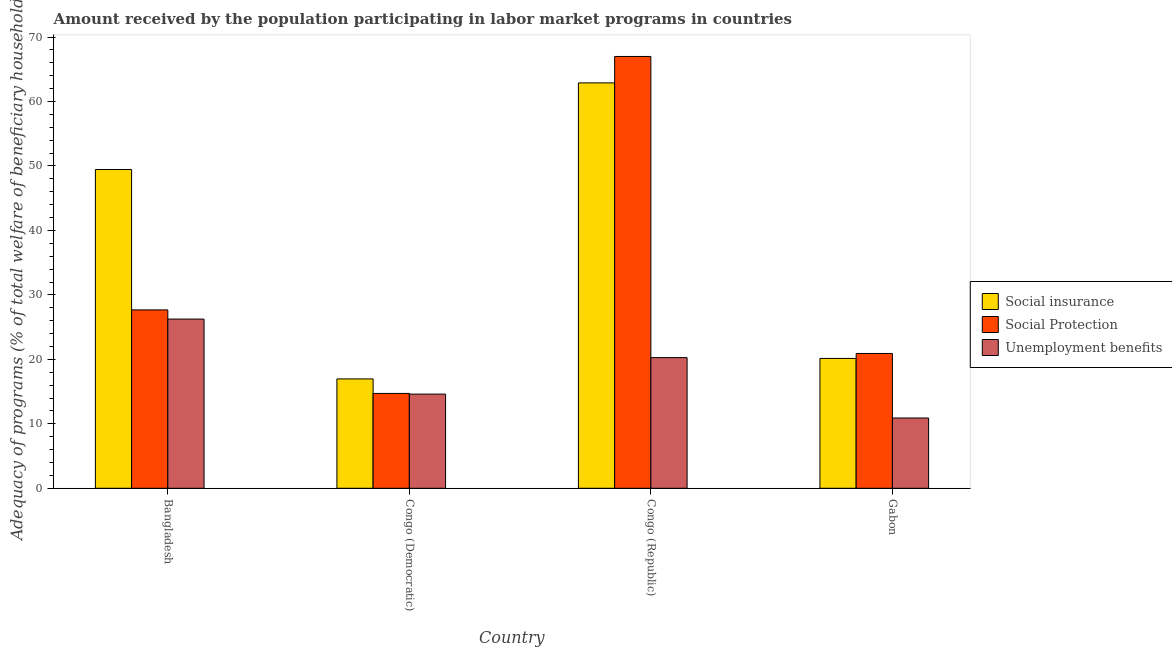How many different coloured bars are there?
Provide a succinct answer. 3. How many groups of bars are there?
Ensure brevity in your answer.  4. Are the number of bars per tick equal to the number of legend labels?
Provide a succinct answer. Yes. What is the label of the 2nd group of bars from the left?
Give a very brief answer. Congo (Democratic). What is the amount received by the population participating in social insurance programs in Bangladesh?
Give a very brief answer. 49.45. Across all countries, what is the maximum amount received by the population participating in unemployment benefits programs?
Give a very brief answer. 26.25. Across all countries, what is the minimum amount received by the population participating in unemployment benefits programs?
Keep it short and to the point. 10.9. In which country was the amount received by the population participating in social protection programs maximum?
Provide a succinct answer. Congo (Republic). In which country was the amount received by the population participating in social insurance programs minimum?
Your answer should be very brief. Congo (Democratic). What is the total amount received by the population participating in social insurance programs in the graph?
Your answer should be very brief. 149.45. What is the difference between the amount received by the population participating in social insurance programs in Bangladesh and that in Gabon?
Make the answer very short. 29.31. What is the difference between the amount received by the population participating in social protection programs in Bangladesh and the amount received by the population participating in social insurance programs in Congo (Democratic)?
Ensure brevity in your answer.  10.71. What is the average amount received by the population participating in social insurance programs per country?
Your response must be concise. 37.36. What is the difference between the amount received by the population participating in social protection programs and amount received by the population participating in unemployment benefits programs in Gabon?
Your response must be concise. 10.01. What is the ratio of the amount received by the population participating in social protection programs in Congo (Democratic) to that in Gabon?
Keep it short and to the point. 0.7. Is the amount received by the population participating in social protection programs in Congo (Democratic) less than that in Congo (Republic)?
Your answer should be very brief. Yes. What is the difference between the highest and the second highest amount received by the population participating in unemployment benefits programs?
Offer a very short reply. 5.98. What is the difference between the highest and the lowest amount received by the population participating in unemployment benefits programs?
Your answer should be very brief. 15.35. In how many countries, is the amount received by the population participating in social insurance programs greater than the average amount received by the population participating in social insurance programs taken over all countries?
Provide a short and direct response. 2. Is the sum of the amount received by the population participating in social insurance programs in Congo (Republic) and Gabon greater than the maximum amount received by the population participating in social protection programs across all countries?
Give a very brief answer. Yes. What does the 1st bar from the left in Congo (Republic) represents?
Ensure brevity in your answer.  Social insurance. What does the 2nd bar from the right in Gabon represents?
Your answer should be compact. Social Protection. Is it the case that in every country, the sum of the amount received by the population participating in social insurance programs and amount received by the population participating in social protection programs is greater than the amount received by the population participating in unemployment benefits programs?
Keep it short and to the point. Yes. Are all the bars in the graph horizontal?
Provide a short and direct response. No. How many countries are there in the graph?
Your response must be concise. 4. Does the graph contain grids?
Offer a very short reply. No. How are the legend labels stacked?
Keep it short and to the point. Vertical. What is the title of the graph?
Give a very brief answer. Amount received by the population participating in labor market programs in countries. What is the label or title of the X-axis?
Your answer should be very brief. Country. What is the label or title of the Y-axis?
Keep it short and to the point. Adequacy of programs (% of total welfare of beneficiary households). What is the Adequacy of programs (% of total welfare of beneficiary households) of Social insurance in Bangladesh?
Your answer should be compact. 49.45. What is the Adequacy of programs (% of total welfare of beneficiary households) of Social Protection in Bangladesh?
Offer a terse response. 27.67. What is the Adequacy of programs (% of total welfare of beneficiary households) of Unemployment benefits in Bangladesh?
Provide a succinct answer. 26.25. What is the Adequacy of programs (% of total welfare of beneficiary households) in Social insurance in Congo (Democratic)?
Provide a short and direct response. 16.97. What is the Adequacy of programs (% of total welfare of beneficiary households) of Social Protection in Congo (Democratic)?
Provide a short and direct response. 14.72. What is the Adequacy of programs (% of total welfare of beneficiary households) in Unemployment benefits in Congo (Democratic)?
Provide a succinct answer. 14.61. What is the Adequacy of programs (% of total welfare of beneficiary households) of Social insurance in Congo (Republic)?
Offer a terse response. 62.89. What is the Adequacy of programs (% of total welfare of beneficiary households) of Social Protection in Congo (Republic)?
Offer a very short reply. 66.99. What is the Adequacy of programs (% of total welfare of beneficiary households) of Unemployment benefits in Congo (Republic)?
Ensure brevity in your answer.  20.27. What is the Adequacy of programs (% of total welfare of beneficiary households) in Social insurance in Gabon?
Ensure brevity in your answer.  20.14. What is the Adequacy of programs (% of total welfare of beneficiary households) in Social Protection in Gabon?
Offer a very short reply. 20.91. What is the Adequacy of programs (% of total welfare of beneficiary households) in Unemployment benefits in Gabon?
Ensure brevity in your answer.  10.9. Across all countries, what is the maximum Adequacy of programs (% of total welfare of beneficiary households) in Social insurance?
Your answer should be compact. 62.89. Across all countries, what is the maximum Adequacy of programs (% of total welfare of beneficiary households) in Social Protection?
Offer a very short reply. 66.99. Across all countries, what is the maximum Adequacy of programs (% of total welfare of beneficiary households) in Unemployment benefits?
Your response must be concise. 26.25. Across all countries, what is the minimum Adequacy of programs (% of total welfare of beneficiary households) of Social insurance?
Make the answer very short. 16.97. Across all countries, what is the minimum Adequacy of programs (% of total welfare of beneficiary households) of Social Protection?
Provide a short and direct response. 14.72. Across all countries, what is the minimum Adequacy of programs (% of total welfare of beneficiary households) of Unemployment benefits?
Ensure brevity in your answer.  10.9. What is the total Adequacy of programs (% of total welfare of beneficiary households) of Social insurance in the graph?
Keep it short and to the point. 149.46. What is the total Adequacy of programs (% of total welfare of beneficiary households) of Social Protection in the graph?
Offer a terse response. 130.3. What is the total Adequacy of programs (% of total welfare of beneficiary households) of Unemployment benefits in the graph?
Give a very brief answer. 72.04. What is the difference between the Adequacy of programs (% of total welfare of beneficiary households) of Social insurance in Bangladesh and that in Congo (Democratic)?
Ensure brevity in your answer.  32.49. What is the difference between the Adequacy of programs (% of total welfare of beneficiary households) in Social Protection in Bangladesh and that in Congo (Democratic)?
Your answer should be very brief. 12.96. What is the difference between the Adequacy of programs (% of total welfare of beneficiary households) of Unemployment benefits in Bangladesh and that in Congo (Democratic)?
Provide a succinct answer. 11.64. What is the difference between the Adequacy of programs (% of total welfare of beneficiary households) in Social insurance in Bangladesh and that in Congo (Republic)?
Offer a terse response. -13.44. What is the difference between the Adequacy of programs (% of total welfare of beneficiary households) of Social Protection in Bangladesh and that in Congo (Republic)?
Provide a short and direct response. -39.32. What is the difference between the Adequacy of programs (% of total welfare of beneficiary households) in Unemployment benefits in Bangladesh and that in Congo (Republic)?
Provide a short and direct response. 5.98. What is the difference between the Adequacy of programs (% of total welfare of beneficiary households) in Social insurance in Bangladesh and that in Gabon?
Give a very brief answer. 29.31. What is the difference between the Adequacy of programs (% of total welfare of beneficiary households) in Social Protection in Bangladesh and that in Gabon?
Offer a terse response. 6.76. What is the difference between the Adequacy of programs (% of total welfare of beneficiary households) of Unemployment benefits in Bangladesh and that in Gabon?
Make the answer very short. 15.35. What is the difference between the Adequacy of programs (% of total welfare of beneficiary households) of Social insurance in Congo (Democratic) and that in Congo (Republic)?
Your answer should be compact. -45.92. What is the difference between the Adequacy of programs (% of total welfare of beneficiary households) of Social Protection in Congo (Democratic) and that in Congo (Republic)?
Make the answer very short. -52.28. What is the difference between the Adequacy of programs (% of total welfare of beneficiary households) of Unemployment benefits in Congo (Democratic) and that in Congo (Republic)?
Make the answer very short. -5.66. What is the difference between the Adequacy of programs (% of total welfare of beneficiary households) of Social insurance in Congo (Democratic) and that in Gabon?
Provide a short and direct response. -3.18. What is the difference between the Adequacy of programs (% of total welfare of beneficiary households) of Social Protection in Congo (Democratic) and that in Gabon?
Offer a very short reply. -6.2. What is the difference between the Adequacy of programs (% of total welfare of beneficiary households) in Unemployment benefits in Congo (Democratic) and that in Gabon?
Provide a short and direct response. 3.71. What is the difference between the Adequacy of programs (% of total welfare of beneficiary households) of Social insurance in Congo (Republic) and that in Gabon?
Provide a succinct answer. 42.75. What is the difference between the Adequacy of programs (% of total welfare of beneficiary households) of Social Protection in Congo (Republic) and that in Gabon?
Keep it short and to the point. 46.08. What is the difference between the Adequacy of programs (% of total welfare of beneficiary households) of Unemployment benefits in Congo (Republic) and that in Gabon?
Give a very brief answer. 9.37. What is the difference between the Adequacy of programs (% of total welfare of beneficiary households) of Social insurance in Bangladesh and the Adequacy of programs (% of total welfare of beneficiary households) of Social Protection in Congo (Democratic)?
Provide a succinct answer. 34.74. What is the difference between the Adequacy of programs (% of total welfare of beneficiary households) of Social insurance in Bangladesh and the Adequacy of programs (% of total welfare of beneficiary households) of Unemployment benefits in Congo (Democratic)?
Offer a very short reply. 34.84. What is the difference between the Adequacy of programs (% of total welfare of beneficiary households) of Social Protection in Bangladesh and the Adequacy of programs (% of total welfare of beneficiary households) of Unemployment benefits in Congo (Democratic)?
Offer a terse response. 13.06. What is the difference between the Adequacy of programs (% of total welfare of beneficiary households) in Social insurance in Bangladesh and the Adequacy of programs (% of total welfare of beneficiary households) in Social Protection in Congo (Republic)?
Your response must be concise. -17.54. What is the difference between the Adequacy of programs (% of total welfare of beneficiary households) of Social insurance in Bangladesh and the Adequacy of programs (% of total welfare of beneficiary households) of Unemployment benefits in Congo (Republic)?
Give a very brief answer. 29.18. What is the difference between the Adequacy of programs (% of total welfare of beneficiary households) of Social Protection in Bangladesh and the Adequacy of programs (% of total welfare of beneficiary households) of Unemployment benefits in Congo (Republic)?
Provide a succinct answer. 7.4. What is the difference between the Adequacy of programs (% of total welfare of beneficiary households) in Social insurance in Bangladesh and the Adequacy of programs (% of total welfare of beneficiary households) in Social Protection in Gabon?
Offer a terse response. 28.54. What is the difference between the Adequacy of programs (% of total welfare of beneficiary households) of Social insurance in Bangladesh and the Adequacy of programs (% of total welfare of beneficiary households) of Unemployment benefits in Gabon?
Your response must be concise. 38.55. What is the difference between the Adequacy of programs (% of total welfare of beneficiary households) in Social Protection in Bangladesh and the Adequacy of programs (% of total welfare of beneficiary households) in Unemployment benefits in Gabon?
Provide a short and direct response. 16.77. What is the difference between the Adequacy of programs (% of total welfare of beneficiary households) in Social insurance in Congo (Democratic) and the Adequacy of programs (% of total welfare of beneficiary households) in Social Protection in Congo (Republic)?
Your answer should be very brief. -50.03. What is the difference between the Adequacy of programs (% of total welfare of beneficiary households) in Social insurance in Congo (Democratic) and the Adequacy of programs (% of total welfare of beneficiary households) in Unemployment benefits in Congo (Republic)?
Give a very brief answer. -3.31. What is the difference between the Adequacy of programs (% of total welfare of beneficiary households) in Social Protection in Congo (Democratic) and the Adequacy of programs (% of total welfare of beneficiary households) in Unemployment benefits in Congo (Republic)?
Provide a succinct answer. -5.56. What is the difference between the Adequacy of programs (% of total welfare of beneficiary households) of Social insurance in Congo (Democratic) and the Adequacy of programs (% of total welfare of beneficiary households) of Social Protection in Gabon?
Make the answer very short. -3.95. What is the difference between the Adequacy of programs (% of total welfare of beneficiary households) in Social insurance in Congo (Democratic) and the Adequacy of programs (% of total welfare of beneficiary households) in Unemployment benefits in Gabon?
Your answer should be compact. 6.06. What is the difference between the Adequacy of programs (% of total welfare of beneficiary households) in Social Protection in Congo (Democratic) and the Adequacy of programs (% of total welfare of beneficiary households) in Unemployment benefits in Gabon?
Provide a succinct answer. 3.81. What is the difference between the Adequacy of programs (% of total welfare of beneficiary households) of Social insurance in Congo (Republic) and the Adequacy of programs (% of total welfare of beneficiary households) of Social Protection in Gabon?
Your answer should be compact. 41.98. What is the difference between the Adequacy of programs (% of total welfare of beneficiary households) in Social insurance in Congo (Republic) and the Adequacy of programs (% of total welfare of beneficiary households) in Unemployment benefits in Gabon?
Give a very brief answer. 51.99. What is the difference between the Adequacy of programs (% of total welfare of beneficiary households) in Social Protection in Congo (Republic) and the Adequacy of programs (% of total welfare of beneficiary households) in Unemployment benefits in Gabon?
Ensure brevity in your answer.  56.09. What is the average Adequacy of programs (% of total welfare of beneficiary households) in Social insurance per country?
Ensure brevity in your answer.  37.36. What is the average Adequacy of programs (% of total welfare of beneficiary households) of Social Protection per country?
Ensure brevity in your answer.  32.57. What is the average Adequacy of programs (% of total welfare of beneficiary households) in Unemployment benefits per country?
Provide a short and direct response. 18.01. What is the difference between the Adequacy of programs (% of total welfare of beneficiary households) of Social insurance and Adequacy of programs (% of total welfare of beneficiary households) of Social Protection in Bangladesh?
Your answer should be compact. 21.78. What is the difference between the Adequacy of programs (% of total welfare of beneficiary households) of Social insurance and Adequacy of programs (% of total welfare of beneficiary households) of Unemployment benefits in Bangladesh?
Give a very brief answer. 23.2. What is the difference between the Adequacy of programs (% of total welfare of beneficiary households) of Social Protection and Adequacy of programs (% of total welfare of beneficiary households) of Unemployment benefits in Bangladesh?
Give a very brief answer. 1.42. What is the difference between the Adequacy of programs (% of total welfare of beneficiary households) in Social insurance and Adequacy of programs (% of total welfare of beneficiary households) in Social Protection in Congo (Democratic)?
Your response must be concise. 2.25. What is the difference between the Adequacy of programs (% of total welfare of beneficiary households) in Social insurance and Adequacy of programs (% of total welfare of beneficiary households) in Unemployment benefits in Congo (Democratic)?
Your response must be concise. 2.36. What is the difference between the Adequacy of programs (% of total welfare of beneficiary households) of Social Protection and Adequacy of programs (% of total welfare of beneficiary households) of Unemployment benefits in Congo (Democratic)?
Give a very brief answer. 0.11. What is the difference between the Adequacy of programs (% of total welfare of beneficiary households) in Social insurance and Adequacy of programs (% of total welfare of beneficiary households) in Social Protection in Congo (Republic)?
Provide a short and direct response. -4.1. What is the difference between the Adequacy of programs (% of total welfare of beneficiary households) in Social insurance and Adequacy of programs (% of total welfare of beneficiary households) in Unemployment benefits in Congo (Republic)?
Offer a very short reply. 42.62. What is the difference between the Adequacy of programs (% of total welfare of beneficiary households) of Social Protection and Adequacy of programs (% of total welfare of beneficiary households) of Unemployment benefits in Congo (Republic)?
Your answer should be very brief. 46.72. What is the difference between the Adequacy of programs (% of total welfare of beneficiary households) of Social insurance and Adequacy of programs (% of total welfare of beneficiary households) of Social Protection in Gabon?
Offer a terse response. -0.77. What is the difference between the Adequacy of programs (% of total welfare of beneficiary households) of Social insurance and Adequacy of programs (% of total welfare of beneficiary households) of Unemployment benefits in Gabon?
Your response must be concise. 9.24. What is the difference between the Adequacy of programs (% of total welfare of beneficiary households) in Social Protection and Adequacy of programs (% of total welfare of beneficiary households) in Unemployment benefits in Gabon?
Provide a short and direct response. 10.01. What is the ratio of the Adequacy of programs (% of total welfare of beneficiary households) of Social insurance in Bangladesh to that in Congo (Democratic)?
Give a very brief answer. 2.91. What is the ratio of the Adequacy of programs (% of total welfare of beneficiary households) of Social Protection in Bangladesh to that in Congo (Democratic)?
Ensure brevity in your answer.  1.88. What is the ratio of the Adequacy of programs (% of total welfare of beneficiary households) of Unemployment benefits in Bangladesh to that in Congo (Democratic)?
Ensure brevity in your answer.  1.8. What is the ratio of the Adequacy of programs (% of total welfare of beneficiary households) in Social insurance in Bangladesh to that in Congo (Republic)?
Offer a terse response. 0.79. What is the ratio of the Adequacy of programs (% of total welfare of beneficiary households) in Social Protection in Bangladesh to that in Congo (Republic)?
Make the answer very short. 0.41. What is the ratio of the Adequacy of programs (% of total welfare of beneficiary households) in Unemployment benefits in Bangladesh to that in Congo (Republic)?
Your answer should be compact. 1.29. What is the ratio of the Adequacy of programs (% of total welfare of beneficiary households) in Social insurance in Bangladesh to that in Gabon?
Offer a very short reply. 2.45. What is the ratio of the Adequacy of programs (% of total welfare of beneficiary households) in Social Protection in Bangladesh to that in Gabon?
Provide a succinct answer. 1.32. What is the ratio of the Adequacy of programs (% of total welfare of beneficiary households) in Unemployment benefits in Bangladesh to that in Gabon?
Your response must be concise. 2.41. What is the ratio of the Adequacy of programs (% of total welfare of beneficiary households) in Social insurance in Congo (Democratic) to that in Congo (Republic)?
Your answer should be very brief. 0.27. What is the ratio of the Adequacy of programs (% of total welfare of beneficiary households) of Social Protection in Congo (Democratic) to that in Congo (Republic)?
Your response must be concise. 0.22. What is the ratio of the Adequacy of programs (% of total welfare of beneficiary households) in Unemployment benefits in Congo (Democratic) to that in Congo (Republic)?
Make the answer very short. 0.72. What is the ratio of the Adequacy of programs (% of total welfare of beneficiary households) in Social insurance in Congo (Democratic) to that in Gabon?
Offer a terse response. 0.84. What is the ratio of the Adequacy of programs (% of total welfare of beneficiary households) in Social Protection in Congo (Democratic) to that in Gabon?
Provide a succinct answer. 0.7. What is the ratio of the Adequacy of programs (% of total welfare of beneficiary households) in Unemployment benefits in Congo (Democratic) to that in Gabon?
Keep it short and to the point. 1.34. What is the ratio of the Adequacy of programs (% of total welfare of beneficiary households) in Social insurance in Congo (Republic) to that in Gabon?
Provide a short and direct response. 3.12. What is the ratio of the Adequacy of programs (% of total welfare of beneficiary households) in Social Protection in Congo (Republic) to that in Gabon?
Offer a terse response. 3.2. What is the ratio of the Adequacy of programs (% of total welfare of beneficiary households) in Unemployment benefits in Congo (Republic) to that in Gabon?
Ensure brevity in your answer.  1.86. What is the difference between the highest and the second highest Adequacy of programs (% of total welfare of beneficiary households) in Social insurance?
Your response must be concise. 13.44. What is the difference between the highest and the second highest Adequacy of programs (% of total welfare of beneficiary households) of Social Protection?
Your answer should be very brief. 39.32. What is the difference between the highest and the second highest Adequacy of programs (% of total welfare of beneficiary households) in Unemployment benefits?
Provide a short and direct response. 5.98. What is the difference between the highest and the lowest Adequacy of programs (% of total welfare of beneficiary households) in Social insurance?
Keep it short and to the point. 45.92. What is the difference between the highest and the lowest Adequacy of programs (% of total welfare of beneficiary households) of Social Protection?
Offer a very short reply. 52.28. What is the difference between the highest and the lowest Adequacy of programs (% of total welfare of beneficiary households) of Unemployment benefits?
Provide a short and direct response. 15.35. 